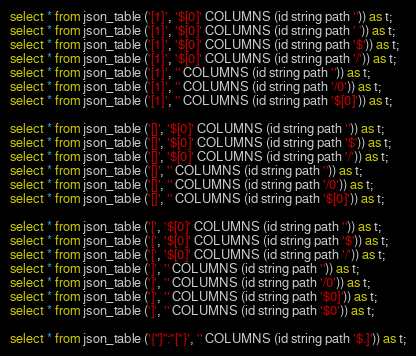<code> <loc_0><loc_0><loc_500><loc_500><_SQL_>select * from json_table ('[1]', '$[0]' COLUMNS (id string path '')) as t;
select * from json_table ('[1]', '$[0]' COLUMNS (id string path ' ')) as t;
select * from json_table ('[1]', '$[0]' COLUMNS (id string path '$')) as t;
select * from json_table ('[1]', '$[0]' COLUMNS (id string path '/')) as t;
select * from json_table ('[1]', '' COLUMNS (id string path '')) as t;
select * from json_table ('[1]', '' COLUMNS (id string path '/0')) as t;
select * from json_table ('[1]', '' COLUMNS (id string path '$[0]')) as t;

select * from json_table ('[]', '$[0]' COLUMNS (id string path '')) as t;
select * from json_table ('[]', '$[0]' COLUMNS (id string path '$')) as t;
select * from json_table ('[]', '$[0]' COLUMNS (id string path '/')) as t;
select * from json_table ('[]', '' COLUMNS (id string path '')) as t;
select * from json_table ('[]', '' COLUMNS (id string path '/0')) as t;
select * from json_table ('[]', '' COLUMNS (id string path '$[0]')) as t;

select * from json_table ('[', '$[0]' COLUMNS (id string path '')) as t;
select * from json_table ('[', '$[0]' COLUMNS (id string path '$')) as t;
select * from json_table ('[', '$[0]' COLUMNS (id string path '/')) as t;
select * from json_table (']', '' COLUMNS (id string path '')) as t;
select * from json_table (']', '' COLUMNS (id string path '/0')) as t;
select * from json_table (']', '' COLUMNS (id string path '$0]')) as t;
select * from json_table (']', '' COLUMNS (id string path '$0')) as t;

select * from json_table ('{"]":"["}', '' COLUMNS (id string path '$.]')) as t;</code> 